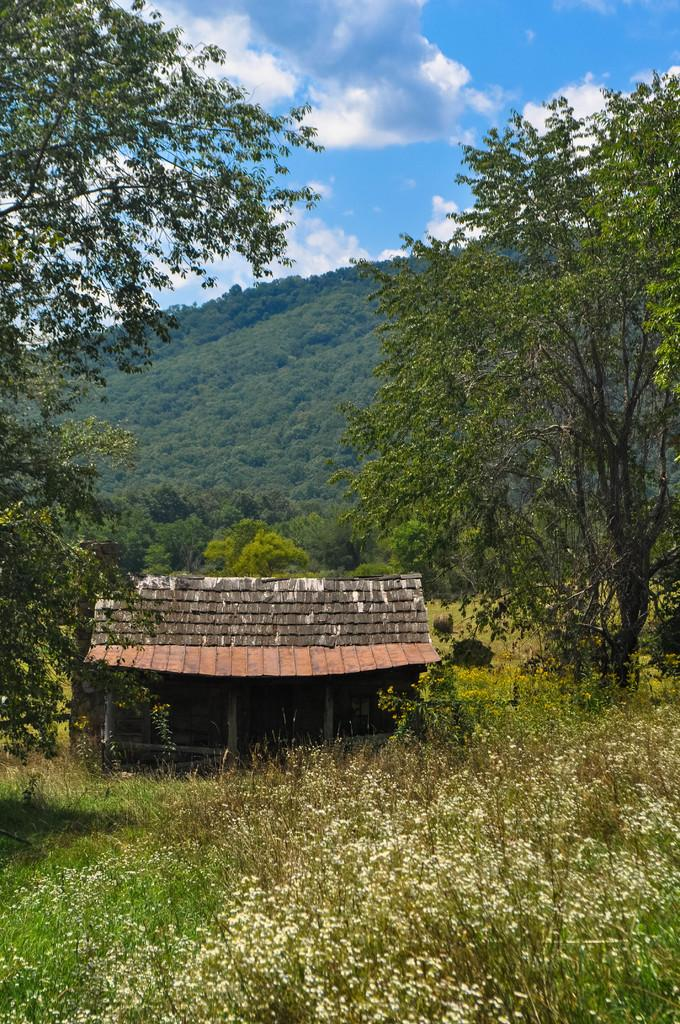What is the main structure in the center of the image? There is a shed in the center of the image. What type of vegetation is present at the bottom of the image? There are plants at the bottom of the image. What type of ground cover is visible in the image? Grass is visible in the image. What can be seen in the background of the image? There are trees, hills, and the sky visible in the background of the image. How does the maid clean the shed in the image? There is no maid present in the image, so it is not possible to answer that question. 